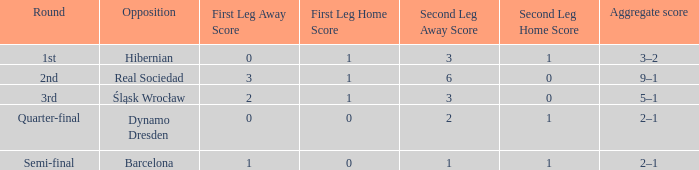What was the first leg of the semi-final? 1–0 (a). 